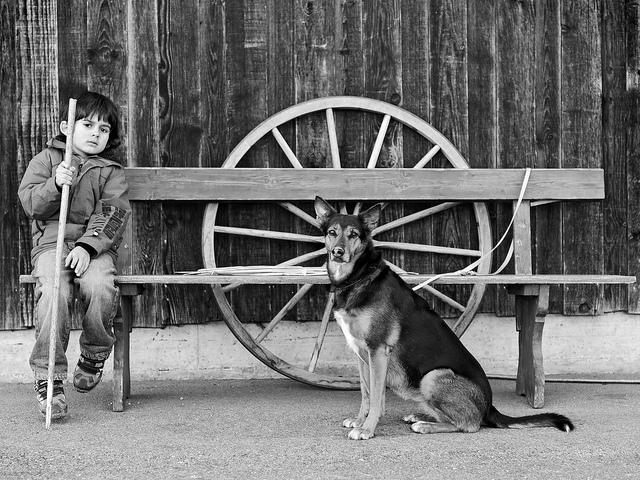Is the dog looking at the camera?
Quick response, please. Yes. What is the boy sitting on?
Answer briefly. Bench. What is the kid holding?
Answer briefly. Stick. 